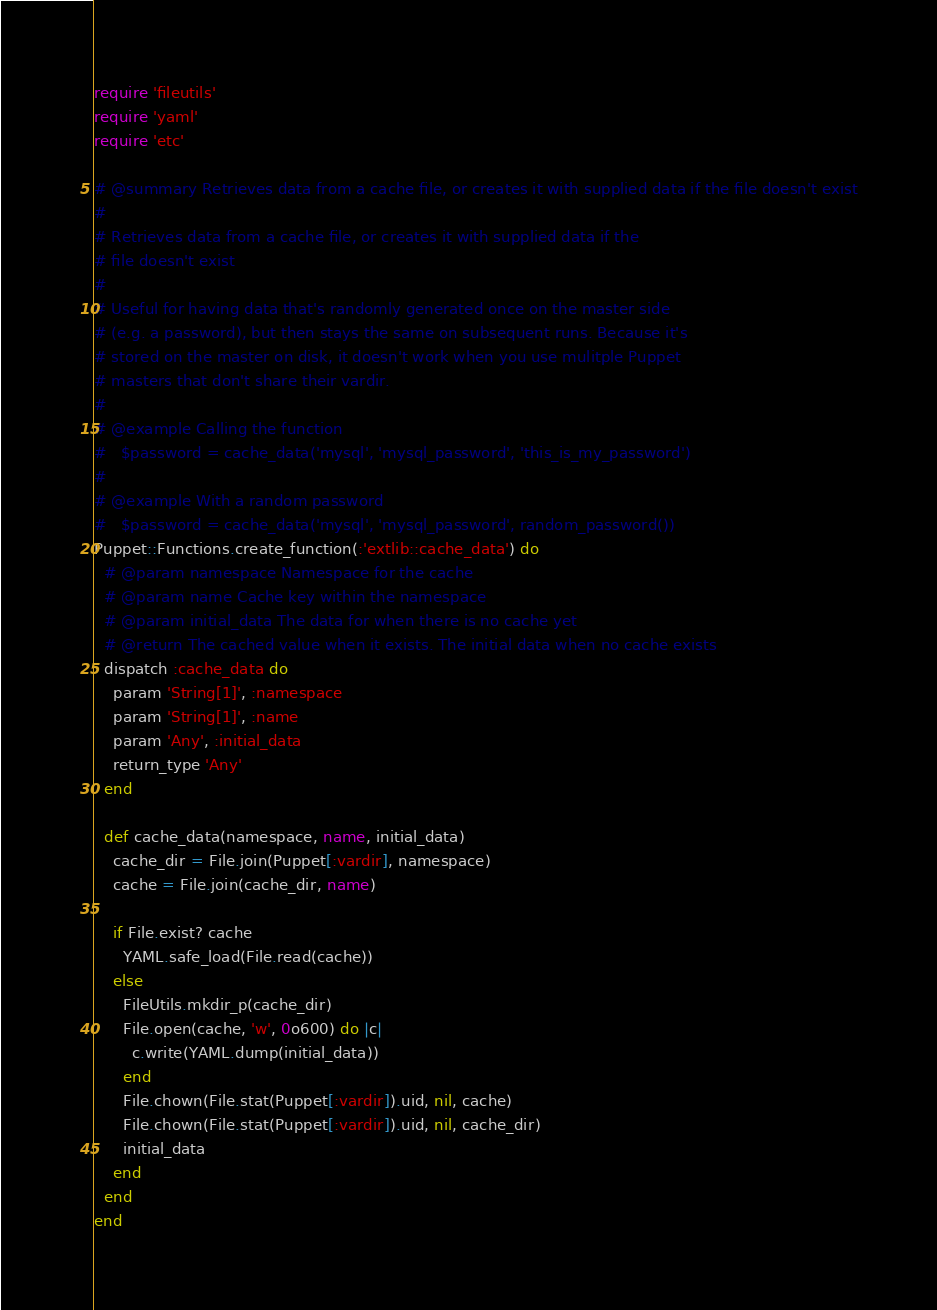Convert code to text. <code><loc_0><loc_0><loc_500><loc_500><_Ruby_>require 'fileutils'
require 'yaml'
require 'etc'

# @summary Retrieves data from a cache file, or creates it with supplied data if the file doesn't exist
#
# Retrieves data from a cache file, or creates it with supplied data if the
# file doesn't exist
#
# Useful for having data that's randomly generated once on the master side
# (e.g. a password), but then stays the same on subsequent runs. Because it's
# stored on the master on disk, it doesn't work when you use mulitple Puppet
# masters that don't share their vardir.
#
# @example Calling the function
#   $password = cache_data('mysql', 'mysql_password', 'this_is_my_password')
#
# @example With a random password
#   $password = cache_data('mysql', 'mysql_password', random_password())
Puppet::Functions.create_function(:'extlib::cache_data') do
  # @param namespace Namespace for the cache
  # @param name Cache key within the namespace
  # @param initial_data The data for when there is no cache yet
  # @return The cached value when it exists. The initial data when no cache exists
  dispatch :cache_data do
    param 'String[1]', :namespace
    param 'String[1]', :name
    param 'Any', :initial_data
    return_type 'Any'
  end

  def cache_data(namespace, name, initial_data)
    cache_dir = File.join(Puppet[:vardir], namespace)
    cache = File.join(cache_dir, name)

    if File.exist? cache
      YAML.safe_load(File.read(cache))
    else
      FileUtils.mkdir_p(cache_dir)
      File.open(cache, 'w', 0o600) do |c|
        c.write(YAML.dump(initial_data))
      end
      File.chown(File.stat(Puppet[:vardir]).uid, nil, cache)
      File.chown(File.stat(Puppet[:vardir]).uid, nil, cache_dir)
      initial_data
    end
  end
end
</code> 